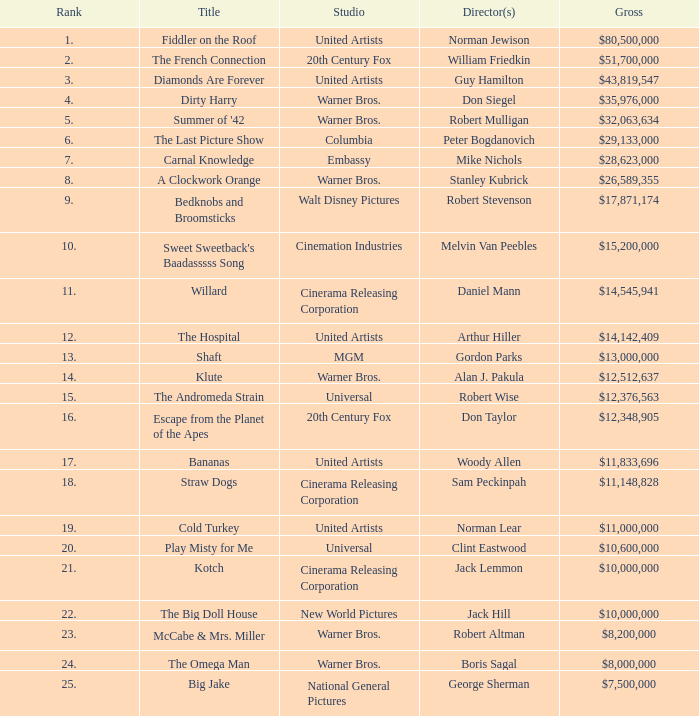What is the rank of The Big Doll House? 22.0. 